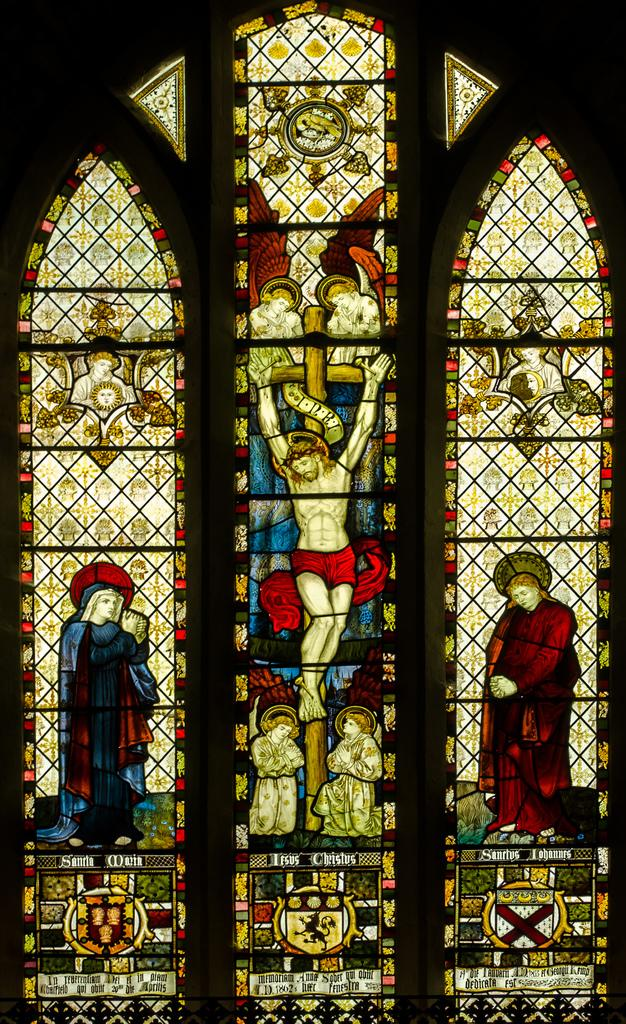What can be seen on the windows in the image? There are paintings on the windows in the image. What is the color of the background in the image? The background of the image is dark. What type of rod can be seen holding up the paintings on the windows? There is no rod visible in the image; the paintings are directly on the windows. Is it raining in the image? There is no indication of rain in the image, as the focus is on the windows and their paintings. 